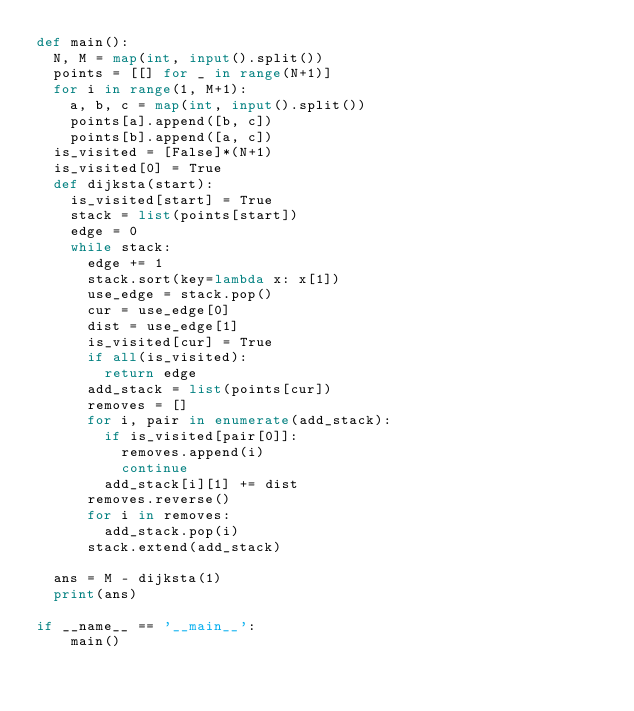Convert code to text. <code><loc_0><loc_0><loc_500><loc_500><_Python_>def main():
	N, M = map(int, input().split())
	points = [[] for _ in range(N+1)]
	for i in range(1, M+1):
		a, b, c = map(int, input().split())
		points[a].append([b, c])
		points[b].append([a, c])
	is_visited = [False]*(N+1)
	is_visited[0] = True
	def dijksta(start):
		is_visited[start] = True
		stack = list(points[start])
		edge = 0
		while stack:
			edge += 1
			stack.sort(key=lambda x: x[1])
			use_edge = stack.pop()
			cur = use_edge[0]
			dist = use_edge[1]
			is_visited[cur] = True
			if all(is_visited):
				return edge
			add_stack = list(points[cur])
			removes = []
			for i, pair in enumerate(add_stack):
				if is_visited[pair[0]]:
					removes.append(i)
					continue
				add_stack[i][1] += dist
			removes.reverse()
			for i in removes:
				add_stack.pop(i)
			stack.extend(add_stack)

	ans = M - dijksta(1)
	print(ans)

if __name__ == '__main__':
    main()</code> 